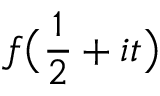<formula> <loc_0><loc_0><loc_500><loc_500>f { \left ( } { \frac { 1 } { 2 } } + i t { \right ) }</formula> 